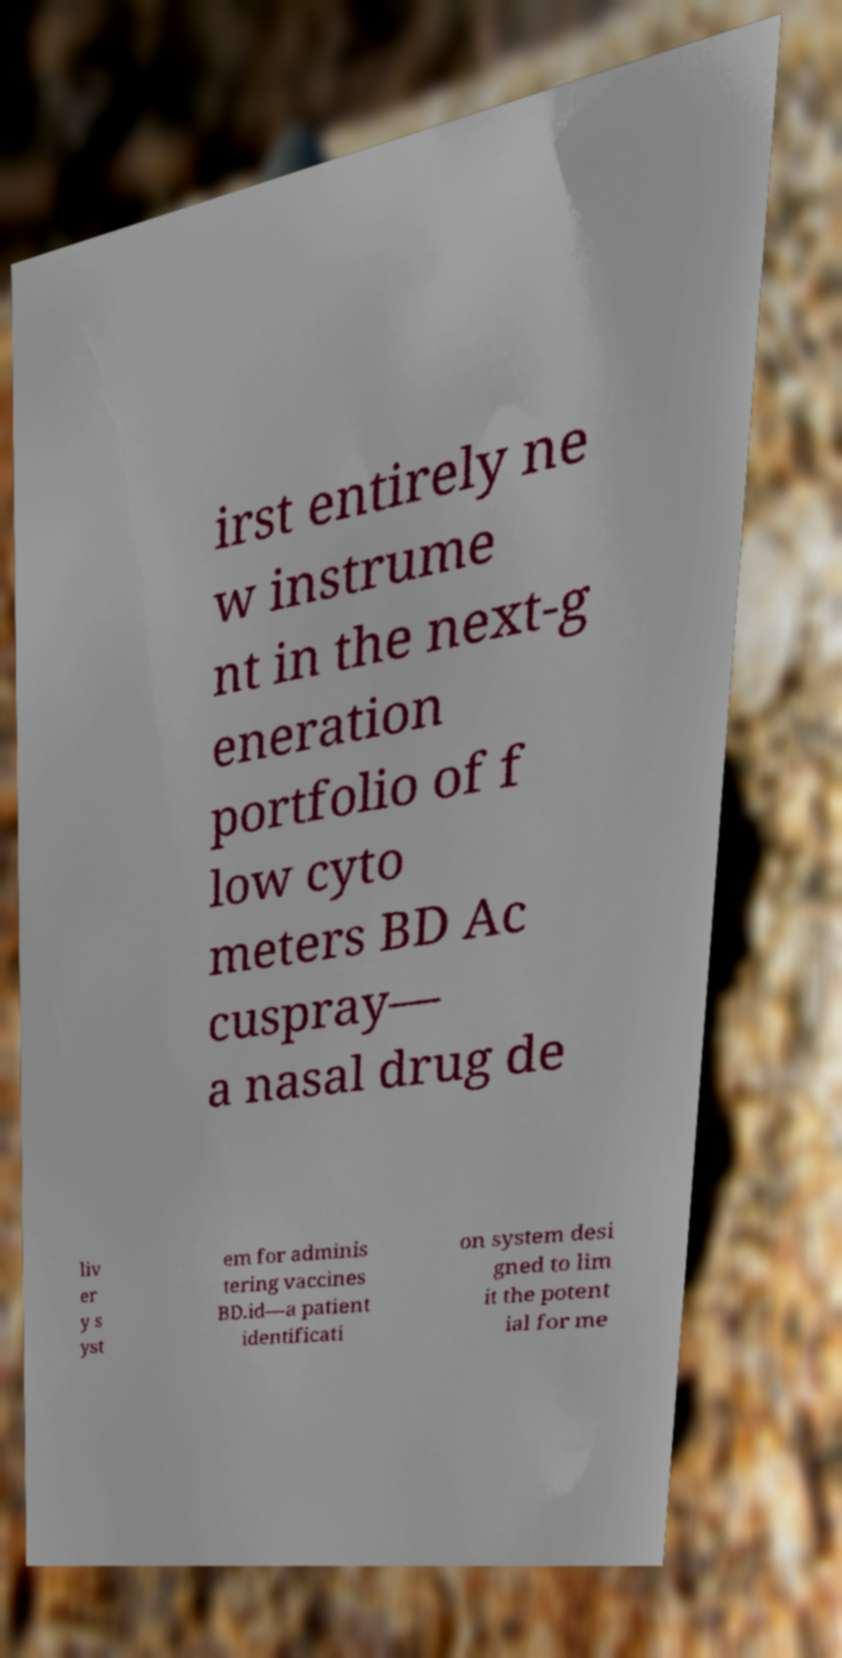I need the written content from this picture converted into text. Can you do that? irst entirely ne w instrume nt in the next-g eneration portfolio of f low cyto meters BD Ac cuspray— a nasal drug de liv er y s yst em for adminis tering vaccines BD.id—a patient identificati on system desi gned to lim it the potent ial for me 